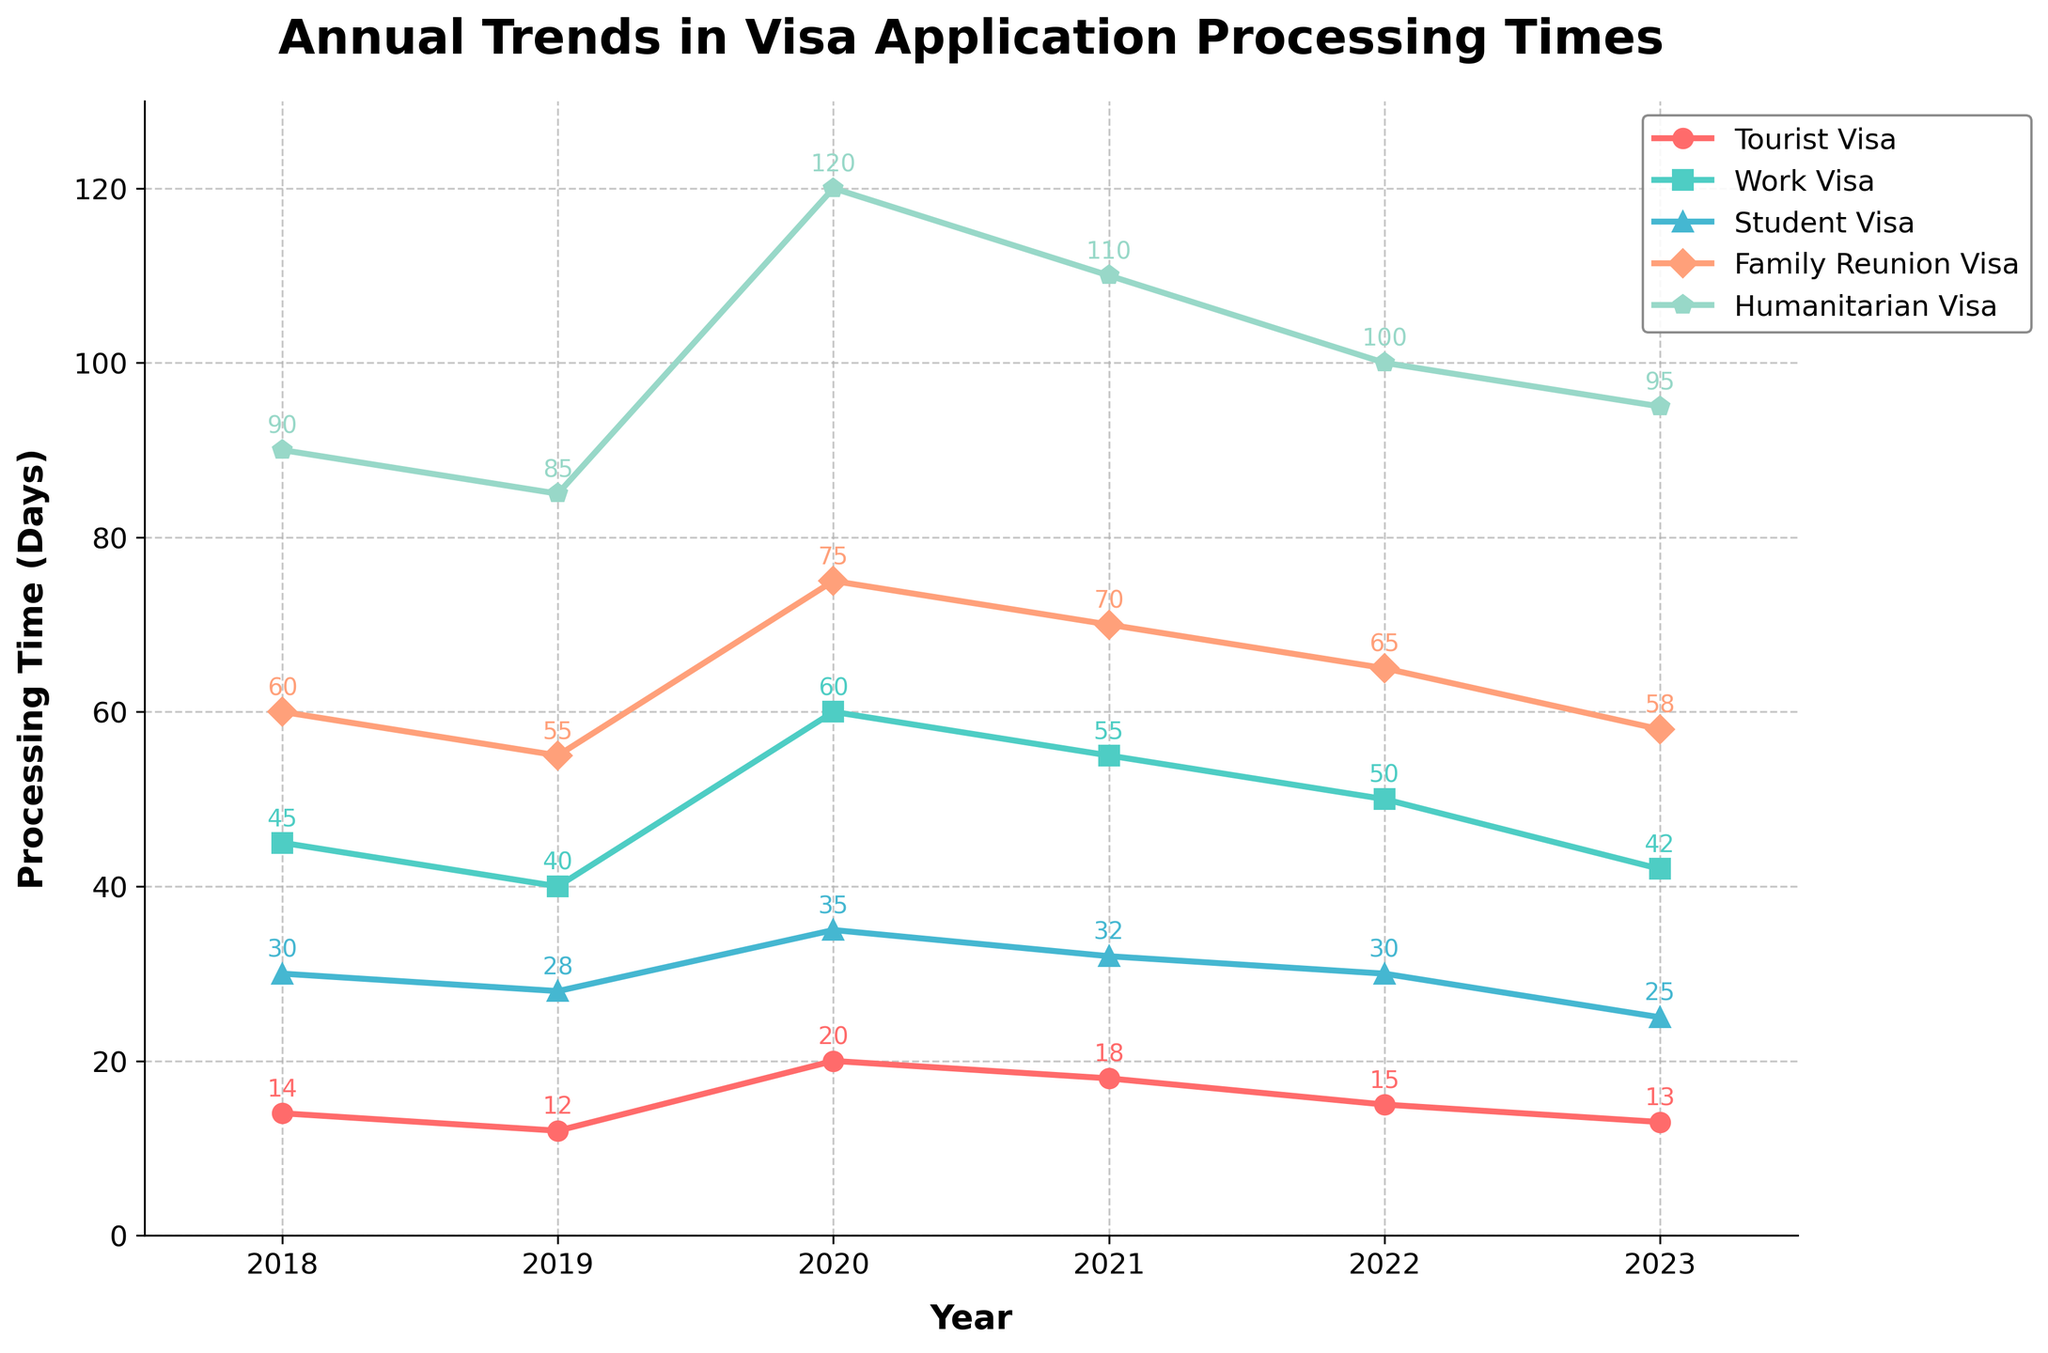What's the average processing time for Tourist Visas over the years? To calculate the average processing time for Tourist Visas from 2018 to 2023, sum up the processing times (14 + 12 + 20 + 18 + 15 + 13 = 92) and then divide by the number of years (6).
Answer: 15.33 days Which visa category had the highest processing time in 2020? By examining the 2020 data points on the line chart, we see that the Humanitarian Visa category had the highest processing time in 2020 with 120 days.
Answer: Humanitarian Visa Did the processing times for Work Visas increase or decrease from 2018 to 2023? To determine the trend for Work Visa processing times, compare the values from 2018 (45 days) to 2023 (42 days). There is a decrease in processing time.
Answer: Decrease Which year had the shortest processing time for Family Reunion Visas? By looking at the data points for Family Reunion Visa over the years, 2019 had the shortest processing time with 55 days.
Answer: 2019 How did the processing time for Student Visas change from 2018 to 2023? To evaluate the change, compare the processing times for Student Visas in 2018 (30 days) and 2023 (25 days). The processing time decreased by 5 days.
Answer: Decrease by 5 days Which visa category had the most consistent processing times over the years? To identify the most consistent processing times, look for the smallest variation among the visa categories. The Tourist Visa appears to have the least fluctuation ranging from 12 to 20 days.
Answer: Tourist Visa What is the percentage decrease in processing time for Tourist Visas from 2020 to 2023? The processing time for Tourist Visas in 2020 was 20 days and in 2023 it was 13 days. The decrease is (20 - 13 = 7 days). The percentage decrease is (7/20) * 100 = 35%.
Answer: 35% Overall, which visa category experienced the highest increase in processing times? Compare the processing time increases from 2018 to 2023 across all visa categories. The Humanitarian Visa increased from 90 days to 95 days, a 5-day increase, which is smaller compared to the other categories. None showed an overall increase.
Answer: None In which year did the Work Visa processing times peak? By observing the data for Work Visa over the years, the processing times peaked in 2020 at 60 days.
Answer: 2020 